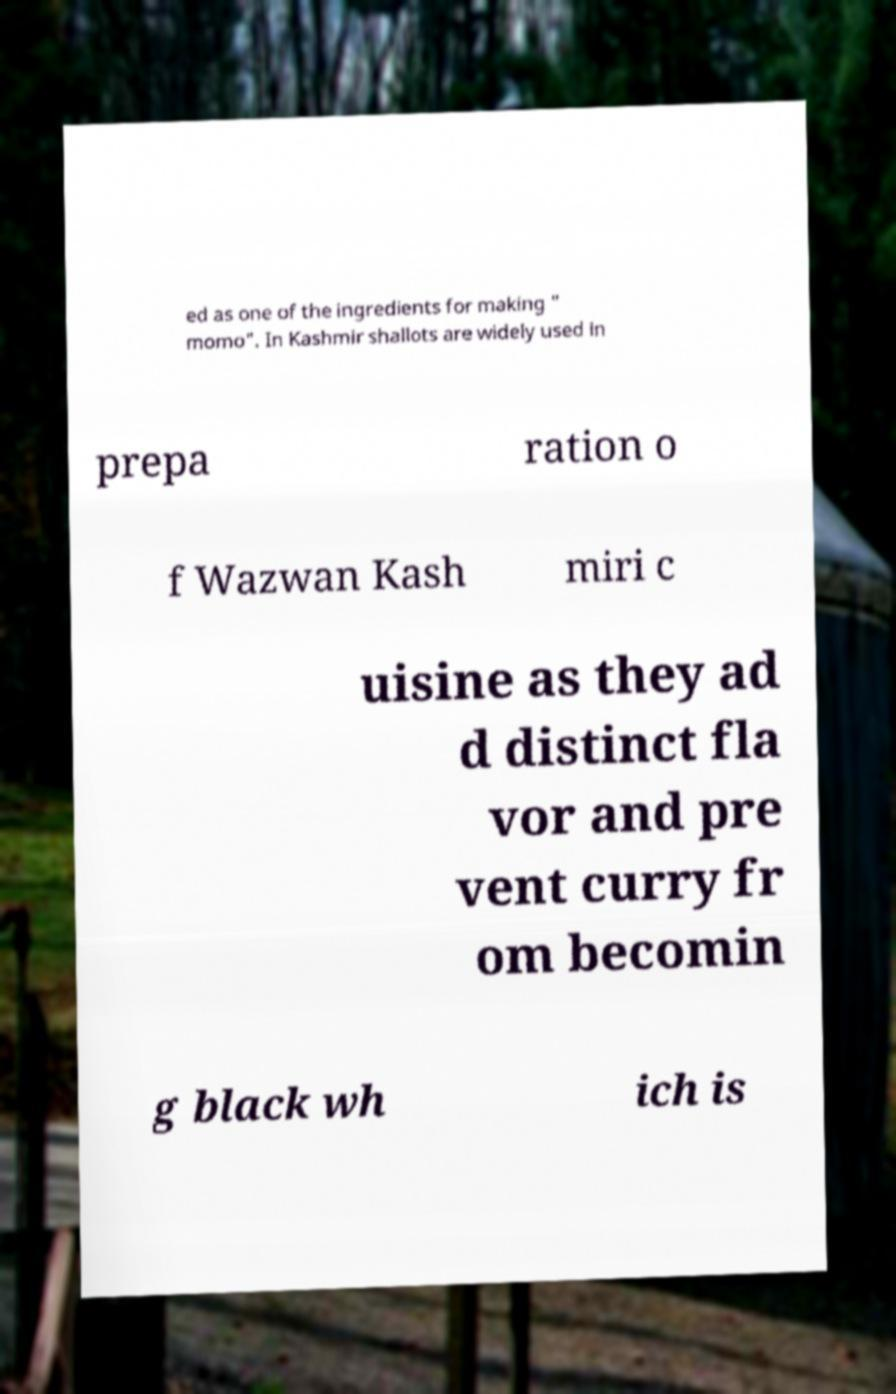Could you assist in decoding the text presented in this image and type it out clearly? ed as one of the ingredients for making " momo". In Kashmir shallots are widely used in prepa ration o f Wazwan Kash miri c uisine as they ad d distinct fla vor and pre vent curry fr om becomin g black wh ich is 